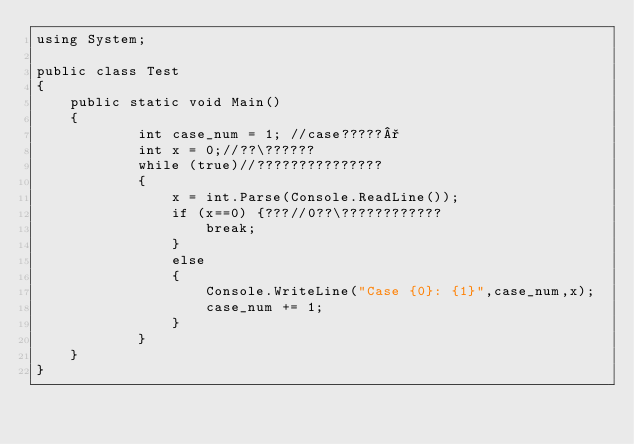Convert code to text. <code><loc_0><loc_0><loc_500><loc_500><_C#_>using System;

public class Test
{
	public static void Main()
	{
            int case_num = 1; //case?????°
            int x = 0;//??\??????
            while (true)//???????????????
            {
                x = int.Parse(Console.ReadLine());
                if (x==0) {???//0??\????????????
                    break;
                }
                else
                {
                    Console.WriteLine("Case {0}: {1}",case_num,x);
                    case_num += 1;
                }
            }
	}
}</code> 